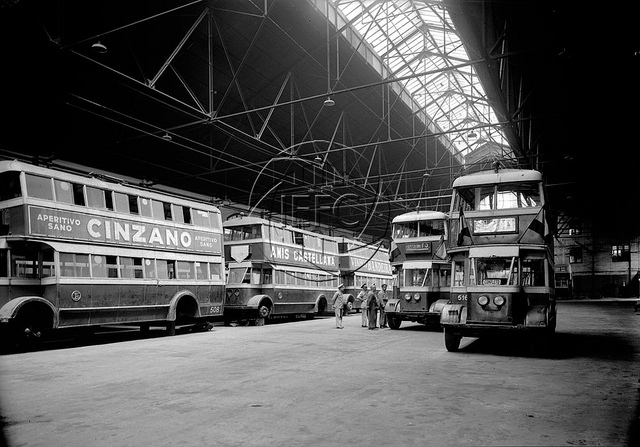Identify the text contained in this image. CINZANO APERITIVO SANO ANIS CASTELLA IEFC 